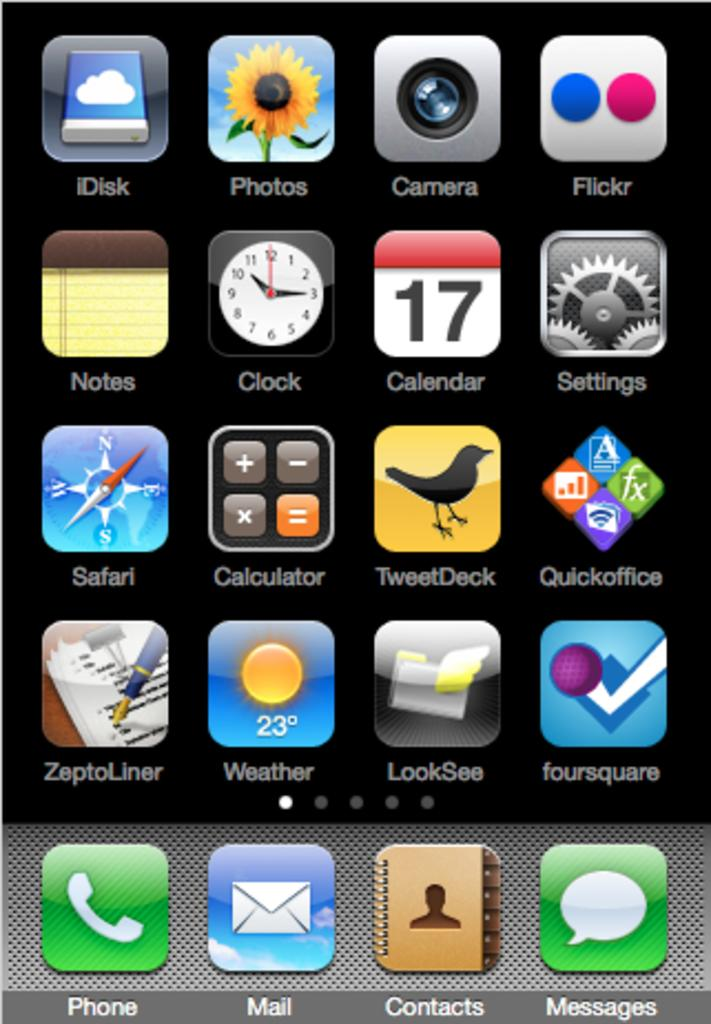What type of screen is shown in the image? The image is a mobile screen. What can be seen on the mobile screen? There are app symbols visible on the screen. How many rabbits are jumping on the shoe in the image? There are no rabbits or shoes present in the image; it only shows a mobile screen with app symbols. 